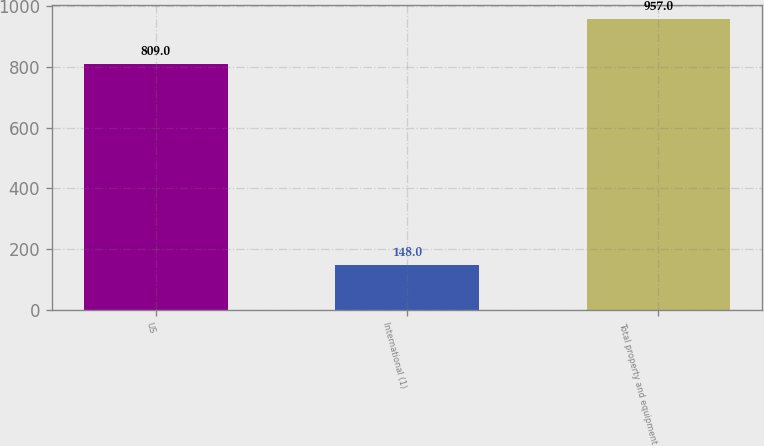Convert chart. <chart><loc_0><loc_0><loc_500><loc_500><bar_chart><fcel>US<fcel>International (1)<fcel>Total property and equipment<nl><fcel>809<fcel>148<fcel>957<nl></chart> 